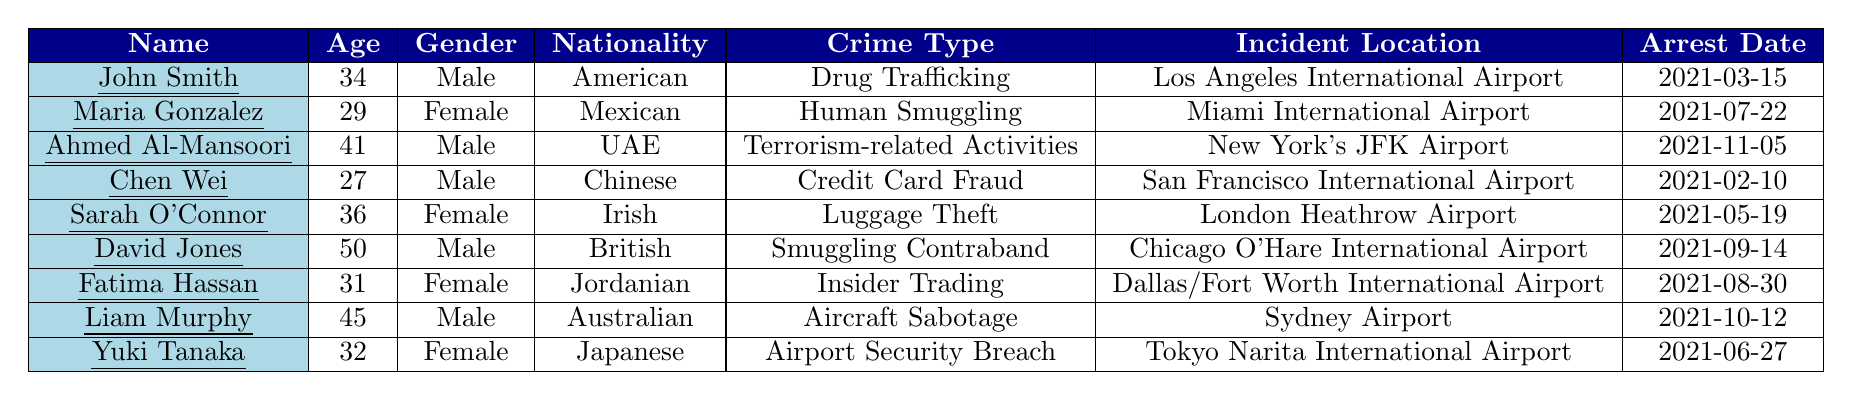What is the age of John Smith? Referring to the table, John Smith's recorded age is 34.
Answer: 34 How many female suspects are listed in the table? The table includes three female suspects: Maria Gonzalez, Sarah O'Connor, and Fatima Hassan.
Answer: 3 What is the nationality of Ahmed Al-Mansoori? The table states that Ahmed Al-Mansoori's nationality is UAE.
Answer: UAE Which crime was committed by Maria Gonzalez? The table indicates that Maria Gonzalez was involved in Human Smuggling.
Answer: Human Smuggling How many suspects are from American nationality? There is only one suspect from American nationality, which is John Smith.
Answer: 1 What crime type did Liam Murphy commit? According to the table, Liam Murphy committed Aircraft Sabotage.
Answer: Aircraft Sabotage Which suspect was arrested on 2021-06-27? The table shows that Yuki Tanaka was arrested on 2021-06-27.
Answer: Yuki Tanaka What is the average age of the suspects in the table? The ages of the suspects are 34, 29, 41, 27, 36, 50, 31, 45, and 32, summing these gives 324, and dividing by the total number of suspects (9) gives an average age of 36.
Answer: 36 Is there a suspect whose crime type is related to insider trading? Yes, the table indicates that Fatima Hassan is involved in Insider Trading.
Answer: Yes What is the incident location for the crime of Luggage Theft? The table states that Luggage Theft occurred at London Heathrow Airport.
Answer: London Heathrow Airport How many suspects are involved in crimes related to drugs? Only one suspect, John Smith, is associated with Drug Trafficking.
Answer: 1 What is the difference in age between the youngest and oldest suspect? The youngest suspect is Chen Wei at 27 years old, and the oldest is David Jones at 50, hence the difference is 50 - 27 = 23 years.
Answer: 23 Which suspects were arrested for crimes related to terrorism? The table shows only one suspect, Ahmed Al-Mansoori, who was arrested for Terrorism-related Activities.
Answer: Ahmed Al-Mansoori What is the total number of suspects from non-American nationalities? There are eight suspects who are not American: Maria Gonzalez, Ahmed Al-Mansoori, Chen Wei, Sarah O'Connor, David Jones, Fatima Hassan, Liam Murphy, and Yuki Tanaka, which totals to 8.
Answer: 8 Was there any suspect arrested at an airport in Japan? Yes, Yuki Tanaka was arrested at Tokyo Narita International Airport.
Answer: Yes 